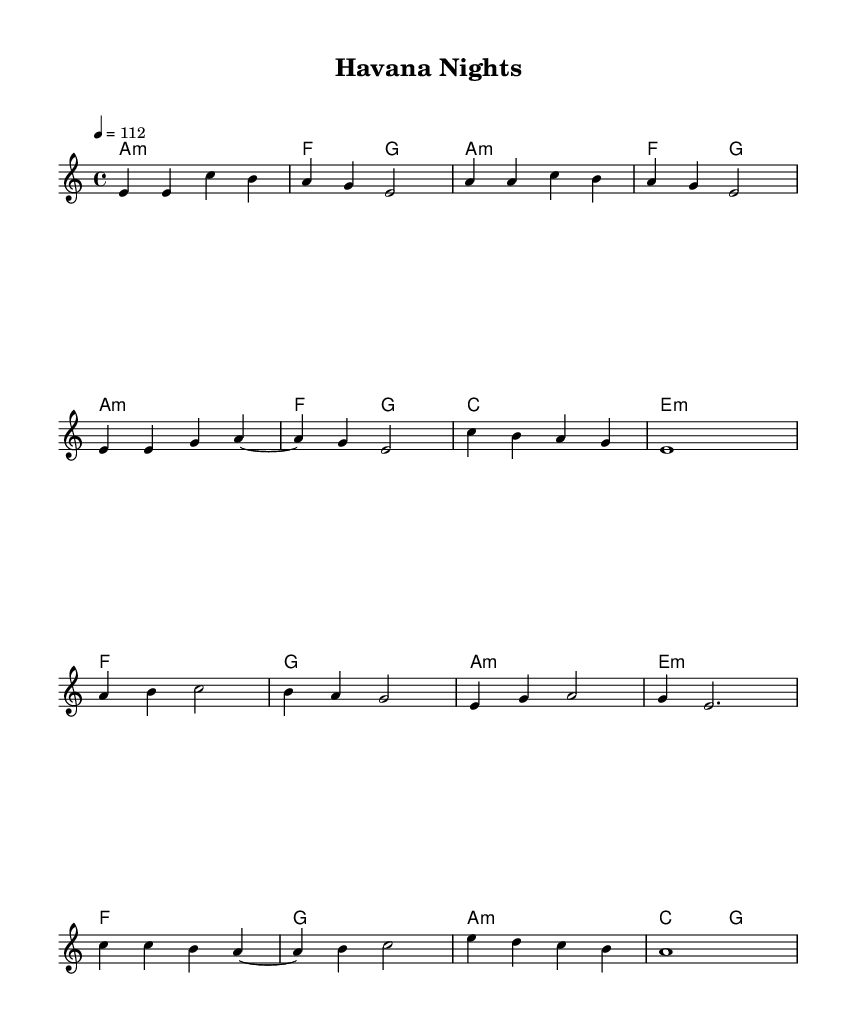What is the key signature of this music? The key signature is A minor, which has no sharps or flats.
Answer: A minor What is the time signature of this music? The time signature is indicated as 4/4, which means there are four beats in each measure.
Answer: 4/4 What is the tempo of this piece? The tempo marking is set to quarter note equals 112 beats per minute, providing a lively pace.
Answer: 112 How many measures are in the verse section? The verse section consists of four measures, as counted from the sheet music.
Answer: 4 What type of chord is primarily used in the chorus? The primary chord used in the chorus is A minor, which is indicated at the start of the chorus section.
Answer: A minor What is the relationship between the pre-chorus and the chorus in terms of harmony? The pre-chorus ends with an E minor chord, and the chorus begins with an F major chord, showing a progression from minor to major harmony.
Answer: Progression from E minor to F major How does the melody in the chorus differ from the verse? The melody in the chorus includes a more open and elevated phrasing, with a prominent and catchy ascent compared to the more stepwise motion in the verse.
Answer: More open and elevated phrasing 